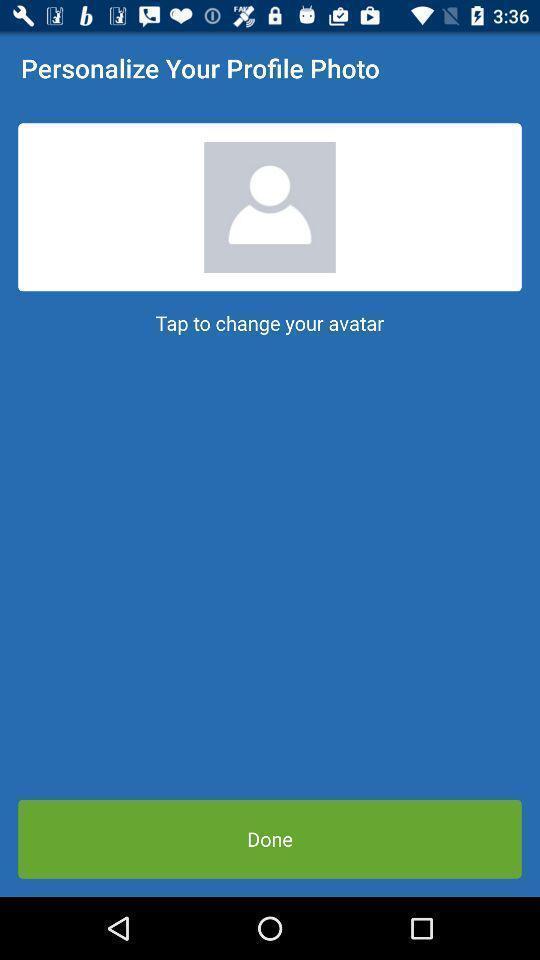Explain the elements present in this screenshot. Personalize option for the your profile photo in the application. 